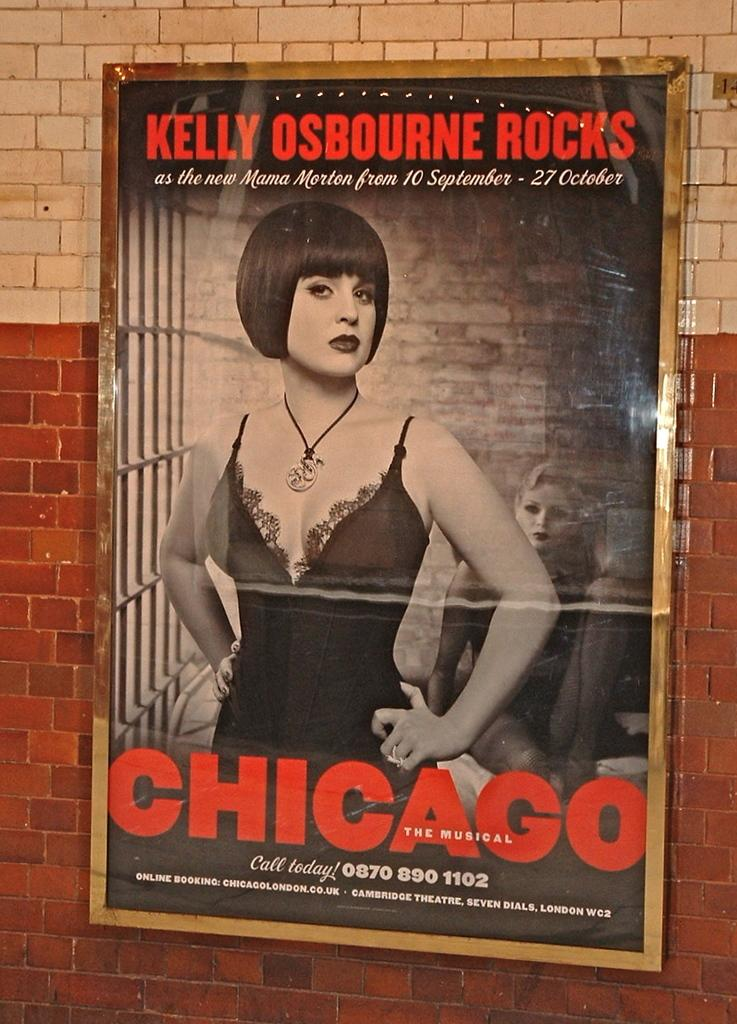<image>
Create a compact narrative representing the image presented. A poster for the musical CHICAGO starring Kelly Osbourne as the new Mama Morton from 10 September - 27 October. 